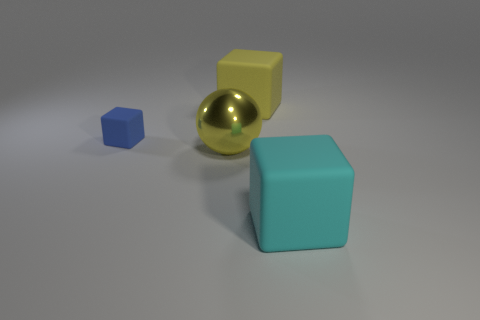Add 1 gray cubes. How many objects exist? 5 Subtract all spheres. How many objects are left? 3 Subtract 0 red cubes. How many objects are left? 4 Subtract all large cyan matte objects. Subtract all big yellow metal spheres. How many objects are left? 2 Add 1 tiny matte cubes. How many tiny matte cubes are left? 2 Add 3 large metal objects. How many large metal objects exist? 4 